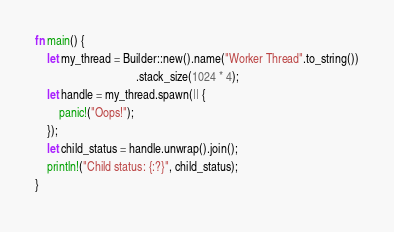<code> <loc_0><loc_0><loc_500><loc_500><_Rust_>fn main() {
    let my_thread = Builder::new().name("Worker Thread".to_string())
                                  .stack_size(1024 * 4);
    let handle = my_thread.spawn(|| {
        panic!("Oops!");
    });
    let child_status = handle.unwrap().join();
    println!("Child status: {:?}", child_status);
}
</code> 